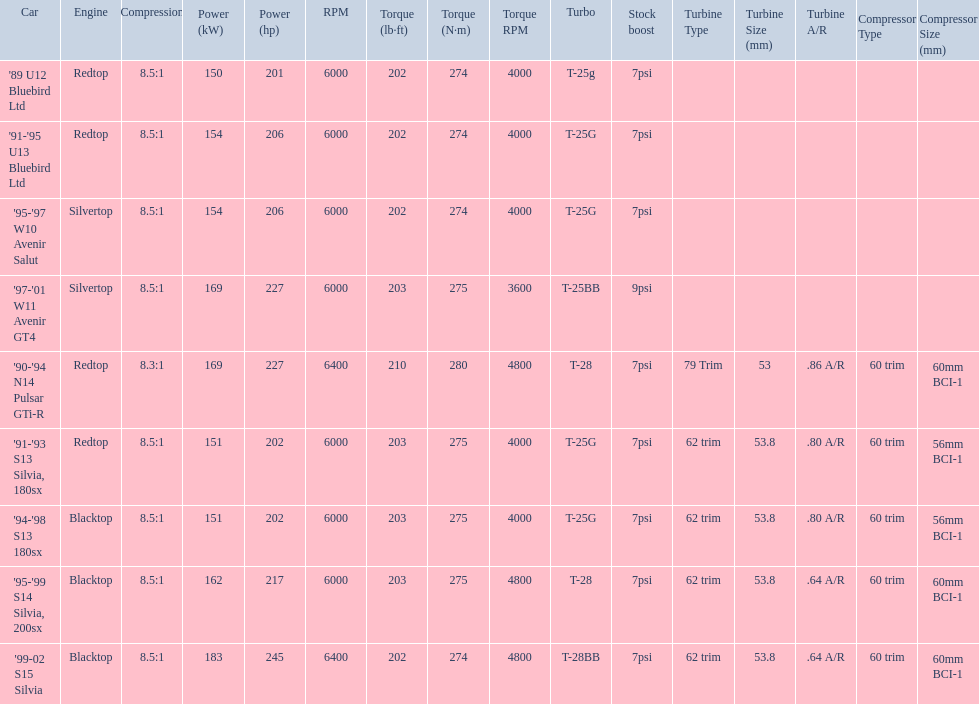What are the listed hp of the cars? 150 kW (201 hp) @ 6000 rpm, 154 kW (206 hp) @ 6000 rpm, 154 kW (206 hp) @ 6000 rpm, 169 kW (227 hp) @ 6000 rpm, 169 kW (227 hp) @ 6400 rpm (Euro: 164 kW (220 hp) @ 6400 rpm), 151 kW (202 hp) @ 6000 rpm, 151 kW (202 hp) @ 6000 rpm, 162 kW (217 hp) @ 6000 rpm, 183 kW (245 hp) @ 6400 rpm. Which is the only car with over 230 hp? '99-02 S15 Silvia. 